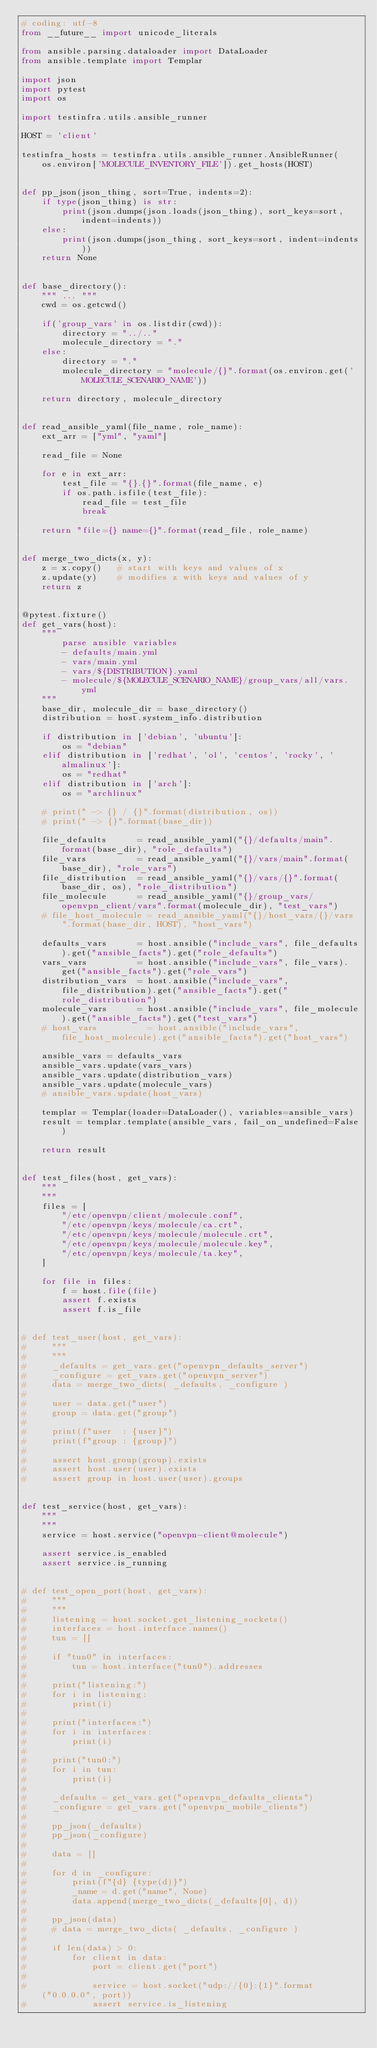<code> <loc_0><loc_0><loc_500><loc_500><_Python_># coding: utf-8
from __future__ import unicode_literals

from ansible.parsing.dataloader import DataLoader
from ansible.template import Templar

import json
import pytest
import os

import testinfra.utils.ansible_runner

HOST = 'client'

testinfra_hosts = testinfra.utils.ansible_runner.AnsibleRunner(
    os.environ['MOLECULE_INVENTORY_FILE']).get_hosts(HOST)


def pp_json(json_thing, sort=True, indents=2):
    if type(json_thing) is str:
        print(json.dumps(json.loads(json_thing), sort_keys=sort, indent=indents))
    else:
        print(json.dumps(json_thing, sort_keys=sort, indent=indents))
    return None


def base_directory():
    """ ... """
    cwd = os.getcwd()

    if('group_vars' in os.listdir(cwd)):
        directory = "../.."
        molecule_directory = "."
    else:
        directory = "."
        molecule_directory = "molecule/{}".format(os.environ.get('MOLECULE_SCENARIO_NAME'))

    return directory, molecule_directory


def read_ansible_yaml(file_name, role_name):
    ext_arr = ["yml", "yaml"]

    read_file = None

    for e in ext_arr:
        test_file = "{}.{}".format(file_name, e)
        if os.path.isfile(test_file):
            read_file = test_file
            break

    return "file={} name={}".format(read_file, role_name)


def merge_two_dicts(x, y):
    z = x.copy()   # start with keys and values of x
    z.update(y)    # modifies z with keys and values of y
    return z


@pytest.fixture()
def get_vars(host):
    """
        parse ansible variables
        - defaults/main.yml
        - vars/main.yml
        - vars/${DISTRIBUTION}.yaml
        - molecule/${MOLECULE_SCENARIO_NAME}/group_vars/all/vars.yml
    """
    base_dir, molecule_dir = base_directory()
    distribution = host.system_info.distribution

    if distribution in ['debian', 'ubuntu']:
        os = "debian"
    elif distribution in ['redhat', 'ol', 'centos', 'rocky', 'almalinux']:
        os = "redhat"
    elif distribution in ['arch']:
        os = "archlinux"

    # print(" -> {} / {}".format(distribution, os))
    # print(" -> {}".format(base_dir))

    file_defaults      = read_ansible_yaml("{}/defaults/main".format(base_dir), "role_defaults")
    file_vars          = read_ansible_yaml("{}/vars/main".format(base_dir), "role_vars")
    file_distribution  = read_ansible_yaml("{}/vars/{}".format(base_dir, os), "role_distribution")
    file_molecule      = read_ansible_yaml("{}/group_vars/openvpn_client/vars".format(molecule_dir), "test_vars")
    # file_host_molecule = read_ansible_yaml("{}/host_vars/{}/vars".format(base_dir, HOST), "host_vars")

    defaults_vars      = host.ansible("include_vars", file_defaults).get("ansible_facts").get("role_defaults")
    vars_vars          = host.ansible("include_vars", file_vars).get("ansible_facts").get("role_vars")
    distribution_vars  = host.ansible("include_vars", file_distribution).get("ansible_facts").get("role_distribution")
    molecule_vars      = host.ansible("include_vars", file_molecule).get("ansible_facts").get("test_vars")
    # host_vars          = host.ansible("include_vars", file_host_molecule).get("ansible_facts").get("host_vars")

    ansible_vars = defaults_vars
    ansible_vars.update(vars_vars)
    ansible_vars.update(distribution_vars)
    ansible_vars.update(molecule_vars)
    # ansible_vars.update(host_vars)

    templar = Templar(loader=DataLoader(), variables=ansible_vars)
    result = templar.template(ansible_vars, fail_on_undefined=False)

    return result


def test_files(host, get_vars):
    """
    """
    files = [
        "/etc/openvpn/client/molecule.conf",
        "/etc/openvpn/keys/molecule/ca.crt",
        "/etc/openvpn/keys/molecule/molecule.crt",
        "/etc/openvpn/keys/molecule/molecule.key",
        "/etc/openvpn/keys/molecule/ta.key",
    ]

    for file in files:
        f = host.file(file)
        assert f.exists
        assert f.is_file


# def test_user(host, get_vars):
#     """
#     """
#     _defaults = get_vars.get("openvpn_defaults_server")
#     _configure = get_vars.get("openvpn_server")
#     data = merge_two_dicts( _defaults, _configure )
#
#     user = data.get("user")
#     group = data.get("group")
#
#     print(f"user  : {user}")
#     print(f"group : {group}")
#
#     assert host.group(group).exists
#     assert host.user(user).exists
#     assert group in host.user(user).groups


def test_service(host, get_vars):
    """
    """
    service = host.service("openvpn-client@molecule")

    assert service.is_enabled
    assert service.is_running


# def test_open_port(host, get_vars):
#     """
#     """
#     listening = host.socket.get_listening_sockets()
#     interfaces = host.interface.names()
#     tun = []
#
#     if "tun0" in interfaces:
#         tun = host.interface("tun0").addresses
#
#     print("listening:")
#     for i in listening:
#         print(i)
#
#     print("interfaces:")
#     for i in interfaces:
#         print(i)
#
#     print("tun0:")
#     for i in tun:
#         print(i)
#
#     _defaults = get_vars.get("openvpn_defaults_clients")
#     _configure = get_vars.get("openvpn_mobile_clients")
#
#     pp_json(_defaults)
#     pp_json(_configure)
#
#     data = []
#
#     for d in _configure:
#         print(f"{d} {type(d)}")
#         _name = d.get("name", None)
#         data.append(merge_two_dicts(_defaults[0], d))
#
#     pp_json(data)
#     # data = merge_two_dicts( _defaults, _configure )
#
#     if len(data) > 0:
#         for client in data:
#             port = client.get("port")
#
#             service = host.socket("udp://{0}:{1}".format("0.0.0.0", port))
#             assert service.is_listening
</code> 